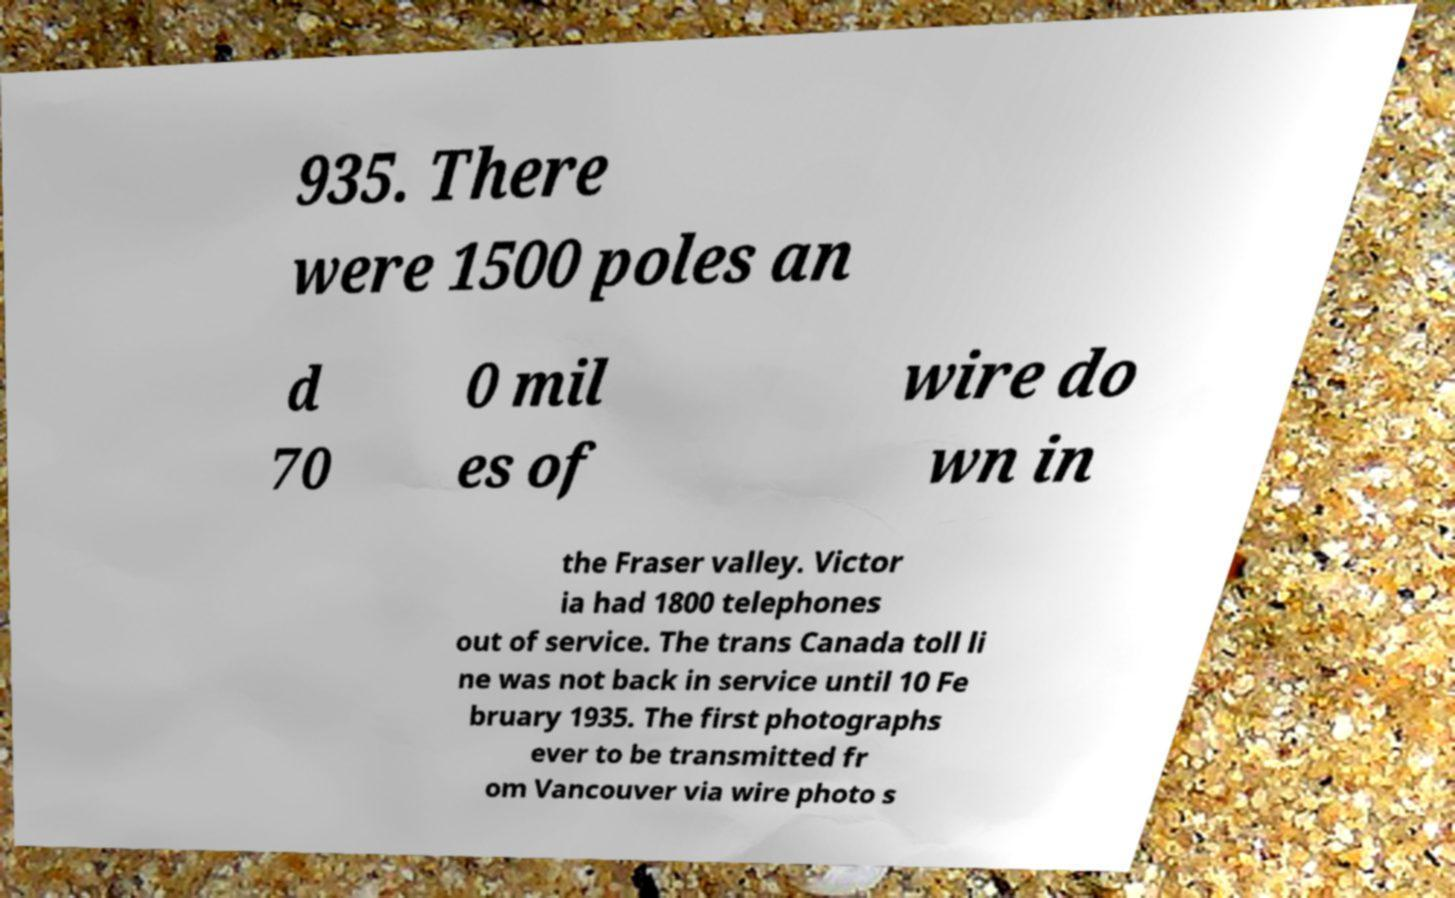I need the written content from this picture converted into text. Can you do that? 935. There were 1500 poles an d 70 0 mil es of wire do wn in the Fraser valley. Victor ia had 1800 telephones out of service. The trans Canada toll li ne was not back in service until 10 Fe bruary 1935. The first photographs ever to be transmitted fr om Vancouver via wire photo s 